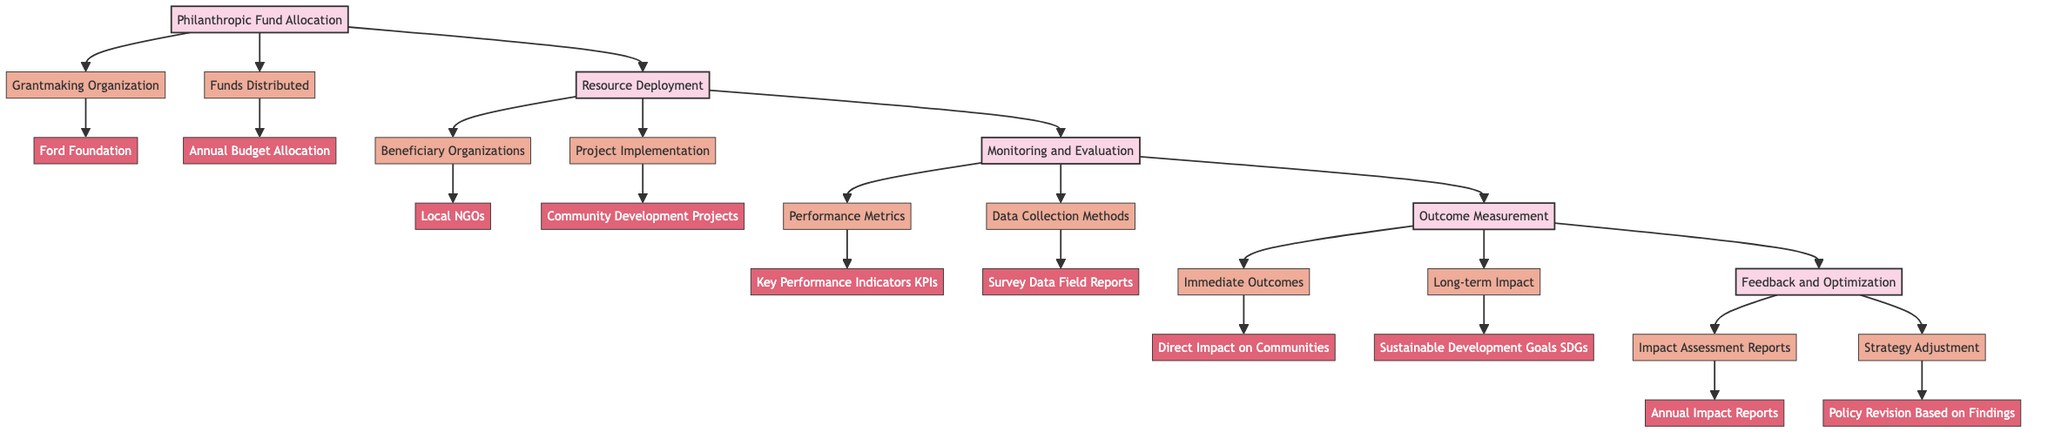What is the main organization mentioned in the diagram? The diagram indicates that the primary grantmaking organization is the Ford Foundation, as specified under the "Grantmaking Organization" sub-element in the "Philanthropic Fund Allocation" block.
Answer: Ford Foundation What type of projects are implemented by beneficiary organizations? The diagram shows that the beneficiary organizations, here identified as local NGOs, are involved in community development projects, specified under the "Project Implementation" sub-element in the "Resource Deployment" block.
Answer: Community Development Projects How many blocks are present in the diagram? The diagram displays a total of five main blocks, which include Philanthropic Fund Allocation, Resource Deployment, Monitoring and Evaluation, Outcome Measurement, and Feedback and Optimization.
Answer: 5 Which data collection methods are utilized in Monitoring and Evaluation? The diagram outlines that the data collection methods include survey data and field reports. This information is derived from the "Data Collection Methods" sub-element in the "Monitoring and Evaluation" block.
Answer: Survey Data, Field Reports What is the immediate outcome stated in the Outcome Measurement block? According to the diagram, the immediate outcome identified is the direct impact on communities. This can be found under the "Immediate Outcomes" sub-element in the "Outcome Measurement" block.
Answer: Direct Impact on Communities How does feedback inform strategy adjustment? The diagram indicates that feedback comes from impact assessment reports, leading to strategy adjustments, which is detailed in the "Feedback and Optimization" block. This illustrates a sequential relationship between assessment and action in philanthropic initiatives.
Answer: Annual Impact Reports What entity is involved in the Feedback and Optimization process? The entity involved is the annual impact reports, indicated as part of the "Impact Assessment Reports" sub-element in the "Feedback and Optimization" block, suggesting its role in evaluating performance.
Answer: Annual Impact Reports What long-term impact is mentioned related to Outcome Measurement? The diagram describes the long-term impact in terms of Sustainable Development Goals, which is included as part of the "Long-term Impact" sub-element in the "Outcome Measurement" block.
Answer: Sustainable Development Goals 